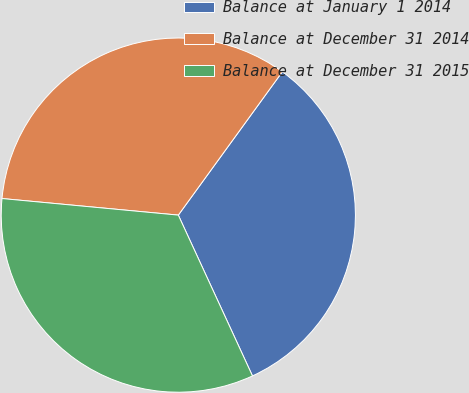Convert chart. <chart><loc_0><loc_0><loc_500><loc_500><pie_chart><fcel>Balance at January 1 2014<fcel>Balance at December 31 2014<fcel>Balance at December 31 2015<nl><fcel>33.13%<fcel>33.5%<fcel>33.37%<nl></chart> 